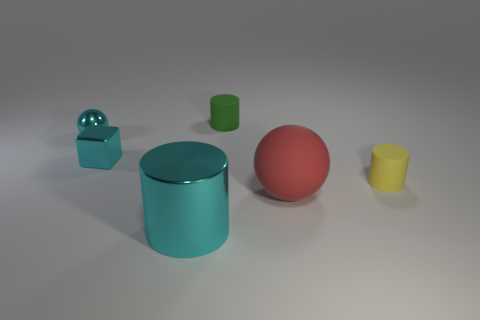What size is the ball that is on the left side of the metal cylinder?
Your response must be concise. Small. There is a cyan object that is in front of the tiny yellow rubber cylinder; what is its material?
Give a very brief answer. Metal. How many blue objects are either big things or small rubber objects?
Provide a short and direct response. 0. Does the cyan sphere have the same material as the big thing that is right of the big cyan cylinder?
Provide a short and direct response. No. Are there the same number of tiny rubber things that are in front of the big red matte sphere and large matte things in front of the small green matte cylinder?
Make the answer very short. No. There is a green rubber cylinder; is its size the same as the ball that is on the right side of the metal cylinder?
Provide a short and direct response. No. Is the number of cyan blocks in front of the large cyan object greater than the number of tiny objects?
Your response must be concise. No. What number of spheres have the same size as the cyan cylinder?
Make the answer very short. 1. There is a sphere that is to the left of the large metal object; is it the same size as the matte cylinder that is to the left of the large matte ball?
Provide a succinct answer. Yes. Is the number of balls that are to the right of the cyan metallic cylinder greater than the number of tiny cyan metal cubes behind the cyan metal sphere?
Keep it short and to the point. Yes. 